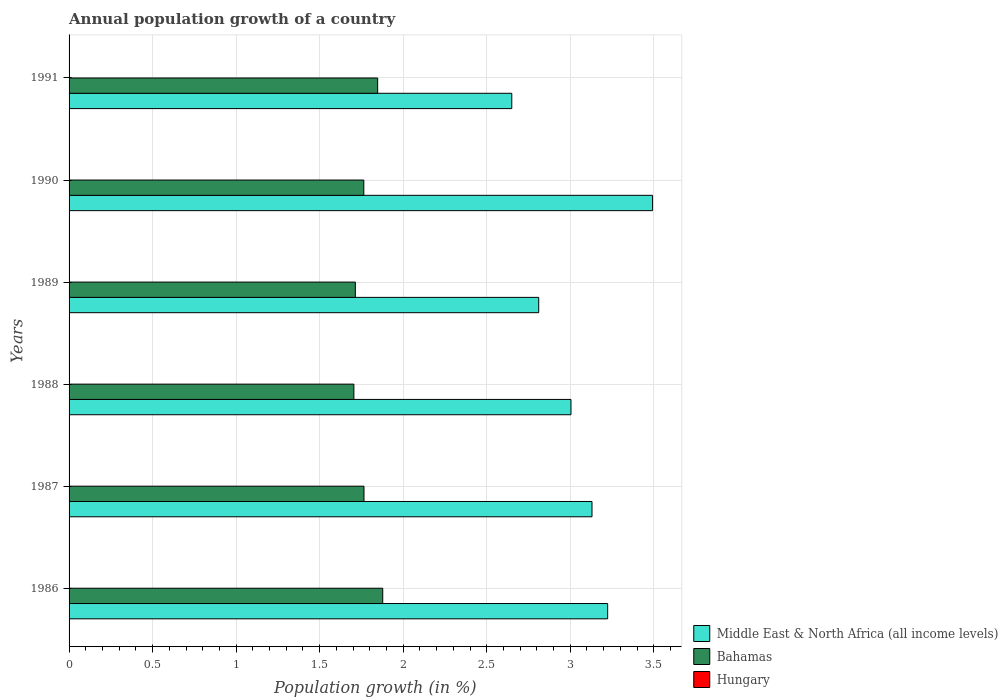How many different coloured bars are there?
Provide a succinct answer. 2. How many groups of bars are there?
Give a very brief answer. 6. Are the number of bars per tick equal to the number of legend labels?
Your answer should be very brief. No. Are the number of bars on each tick of the Y-axis equal?
Provide a short and direct response. Yes. How many bars are there on the 1st tick from the bottom?
Make the answer very short. 2. In how many cases, is the number of bars for a given year not equal to the number of legend labels?
Your response must be concise. 6. Across all years, what is the maximum annual population growth in Middle East & North Africa (all income levels)?
Your answer should be compact. 3.49. Across all years, what is the minimum annual population growth in Hungary?
Your response must be concise. 0. In which year was the annual population growth in Bahamas maximum?
Give a very brief answer. 1986. What is the difference between the annual population growth in Bahamas in 1986 and that in 1987?
Your response must be concise. 0.11. What is the difference between the annual population growth in Hungary in 1988 and the annual population growth in Bahamas in 1991?
Give a very brief answer. -1.85. What is the average annual population growth in Hungary per year?
Provide a succinct answer. 0. In the year 1989, what is the difference between the annual population growth in Bahamas and annual population growth in Middle East & North Africa (all income levels)?
Make the answer very short. -1.1. What is the ratio of the annual population growth in Middle East & North Africa (all income levels) in 1986 to that in 1990?
Your answer should be compact. 0.92. Is the difference between the annual population growth in Bahamas in 1987 and 1989 greater than the difference between the annual population growth in Middle East & North Africa (all income levels) in 1987 and 1989?
Provide a short and direct response. No. What is the difference between the highest and the second highest annual population growth in Bahamas?
Your answer should be very brief. 0.03. What is the difference between the highest and the lowest annual population growth in Middle East & North Africa (all income levels)?
Provide a short and direct response. 0.84. Is the sum of the annual population growth in Bahamas in 1987 and 1990 greater than the maximum annual population growth in Hungary across all years?
Keep it short and to the point. Yes. Is it the case that in every year, the sum of the annual population growth in Hungary and annual population growth in Bahamas is greater than the annual population growth in Middle East & North Africa (all income levels)?
Offer a terse response. No. Are all the bars in the graph horizontal?
Ensure brevity in your answer.  Yes. Are the values on the major ticks of X-axis written in scientific E-notation?
Your answer should be very brief. No. Does the graph contain any zero values?
Give a very brief answer. Yes. Does the graph contain grids?
Make the answer very short. Yes. Where does the legend appear in the graph?
Keep it short and to the point. Bottom right. How are the legend labels stacked?
Ensure brevity in your answer.  Vertical. What is the title of the graph?
Your response must be concise. Annual population growth of a country. Does "Mauritania" appear as one of the legend labels in the graph?
Offer a very short reply. No. What is the label or title of the X-axis?
Give a very brief answer. Population growth (in %). What is the Population growth (in %) in Middle East & North Africa (all income levels) in 1986?
Provide a short and direct response. 3.22. What is the Population growth (in %) of Bahamas in 1986?
Your answer should be compact. 1.88. What is the Population growth (in %) of Hungary in 1986?
Offer a terse response. 0. What is the Population growth (in %) of Middle East & North Africa (all income levels) in 1987?
Ensure brevity in your answer.  3.13. What is the Population growth (in %) of Bahamas in 1987?
Your answer should be very brief. 1.77. What is the Population growth (in %) of Hungary in 1987?
Keep it short and to the point. 0. What is the Population growth (in %) of Middle East & North Africa (all income levels) in 1988?
Keep it short and to the point. 3. What is the Population growth (in %) in Bahamas in 1988?
Provide a succinct answer. 1.7. What is the Population growth (in %) of Hungary in 1988?
Offer a very short reply. 0. What is the Population growth (in %) of Middle East & North Africa (all income levels) in 1989?
Give a very brief answer. 2.81. What is the Population growth (in %) of Bahamas in 1989?
Make the answer very short. 1.71. What is the Population growth (in %) in Middle East & North Africa (all income levels) in 1990?
Provide a short and direct response. 3.49. What is the Population growth (in %) in Bahamas in 1990?
Give a very brief answer. 1.76. What is the Population growth (in %) of Middle East & North Africa (all income levels) in 1991?
Your answer should be compact. 2.65. What is the Population growth (in %) in Bahamas in 1991?
Ensure brevity in your answer.  1.85. Across all years, what is the maximum Population growth (in %) of Middle East & North Africa (all income levels)?
Offer a terse response. 3.49. Across all years, what is the maximum Population growth (in %) of Bahamas?
Ensure brevity in your answer.  1.88. Across all years, what is the minimum Population growth (in %) in Middle East & North Africa (all income levels)?
Offer a very short reply. 2.65. Across all years, what is the minimum Population growth (in %) of Bahamas?
Keep it short and to the point. 1.7. What is the total Population growth (in %) of Middle East & North Africa (all income levels) in the graph?
Your response must be concise. 18.31. What is the total Population growth (in %) in Bahamas in the graph?
Provide a short and direct response. 10.67. What is the difference between the Population growth (in %) of Middle East & North Africa (all income levels) in 1986 and that in 1987?
Your answer should be very brief. 0.09. What is the difference between the Population growth (in %) in Bahamas in 1986 and that in 1987?
Give a very brief answer. 0.11. What is the difference between the Population growth (in %) of Middle East & North Africa (all income levels) in 1986 and that in 1988?
Make the answer very short. 0.22. What is the difference between the Population growth (in %) of Bahamas in 1986 and that in 1988?
Keep it short and to the point. 0.17. What is the difference between the Population growth (in %) in Middle East & North Africa (all income levels) in 1986 and that in 1989?
Your response must be concise. 0.41. What is the difference between the Population growth (in %) in Bahamas in 1986 and that in 1989?
Your answer should be compact. 0.16. What is the difference between the Population growth (in %) in Middle East & North Africa (all income levels) in 1986 and that in 1990?
Offer a very short reply. -0.27. What is the difference between the Population growth (in %) of Bahamas in 1986 and that in 1990?
Provide a short and direct response. 0.11. What is the difference between the Population growth (in %) of Middle East & North Africa (all income levels) in 1986 and that in 1991?
Offer a terse response. 0.57. What is the difference between the Population growth (in %) of Bahamas in 1986 and that in 1991?
Give a very brief answer. 0.03. What is the difference between the Population growth (in %) of Middle East & North Africa (all income levels) in 1987 and that in 1988?
Your response must be concise. 0.13. What is the difference between the Population growth (in %) of Bahamas in 1987 and that in 1988?
Keep it short and to the point. 0.06. What is the difference between the Population growth (in %) of Middle East & North Africa (all income levels) in 1987 and that in 1989?
Offer a very short reply. 0.32. What is the difference between the Population growth (in %) in Bahamas in 1987 and that in 1989?
Give a very brief answer. 0.05. What is the difference between the Population growth (in %) of Middle East & North Africa (all income levels) in 1987 and that in 1990?
Offer a very short reply. -0.36. What is the difference between the Population growth (in %) in Middle East & North Africa (all income levels) in 1987 and that in 1991?
Make the answer very short. 0.48. What is the difference between the Population growth (in %) in Bahamas in 1987 and that in 1991?
Your answer should be very brief. -0.08. What is the difference between the Population growth (in %) in Middle East & North Africa (all income levels) in 1988 and that in 1989?
Provide a succinct answer. 0.19. What is the difference between the Population growth (in %) of Bahamas in 1988 and that in 1989?
Provide a short and direct response. -0.01. What is the difference between the Population growth (in %) in Middle East & North Africa (all income levels) in 1988 and that in 1990?
Your answer should be very brief. -0.49. What is the difference between the Population growth (in %) of Bahamas in 1988 and that in 1990?
Make the answer very short. -0.06. What is the difference between the Population growth (in %) in Middle East & North Africa (all income levels) in 1988 and that in 1991?
Provide a short and direct response. 0.35. What is the difference between the Population growth (in %) in Bahamas in 1988 and that in 1991?
Keep it short and to the point. -0.14. What is the difference between the Population growth (in %) of Middle East & North Africa (all income levels) in 1989 and that in 1990?
Your answer should be compact. -0.68. What is the difference between the Population growth (in %) in Bahamas in 1989 and that in 1990?
Provide a short and direct response. -0.05. What is the difference between the Population growth (in %) in Middle East & North Africa (all income levels) in 1989 and that in 1991?
Make the answer very short. 0.16. What is the difference between the Population growth (in %) in Bahamas in 1989 and that in 1991?
Make the answer very short. -0.13. What is the difference between the Population growth (in %) in Middle East & North Africa (all income levels) in 1990 and that in 1991?
Your answer should be very brief. 0.84. What is the difference between the Population growth (in %) of Bahamas in 1990 and that in 1991?
Provide a short and direct response. -0.08. What is the difference between the Population growth (in %) in Middle East & North Africa (all income levels) in 1986 and the Population growth (in %) in Bahamas in 1987?
Provide a succinct answer. 1.46. What is the difference between the Population growth (in %) in Middle East & North Africa (all income levels) in 1986 and the Population growth (in %) in Bahamas in 1988?
Provide a short and direct response. 1.52. What is the difference between the Population growth (in %) in Middle East & North Africa (all income levels) in 1986 and the Population growth (in %) in Bahamas in 1989?
Keep it short and to the point. 1.51. What is the difference between the Population growth (in %) of Middle East & North Africa (all income levels) in 1986 and the Population growth (in %) of Bahamas in 1990?
Offer a terse response. 1.46. What is the difference between the Population growth (in %) of Middle East & North Africa (all income levels) in 1986 and the Population growth (in %) of Bahamas in 1991?
Your answer should be compact. 1.38. What is the difference between the Population growth (in %) in Middle East & North Africa (all income levels) in 1987 and the Population growth (in %) in Bahamas in 1988?
Ensure brevity in your answer.  1.43. What is the difference between the Population growth (in %) in Middle East & North Africa (all income levels) in 1987 and the Population growth (in %) in Bahamas in 1989?
Offer a very short reply. 1.42. What is the difference between the Population growth (in %) of Middle East & North Africa (all income levels) in 1987 and the Population growth (in %) of Bahamas in 1990?
Your answer should be compact. 1.37. What is the difference between the Population growth (in %) of Middle East & North Africa (all income levels) in 1987 and the Population growth (in %) of Bahamas in 1991?
Give a very brief answer. 1.28. What is the difference between the Population growth (in %) of Middle East & North Africa (all income levels) in 1988 and the Population growth (in %) of Bahamas in 1989?
Keep it short and to the point. 1.29. What is the difference between the Population growth (in %) in Middle East & North Africa (all income levels) in 1988 and the Population growth (in %) in Bahamas in 1990?
Offer a very short reply. 1.24. What is the difference between the Population growth (in %) in Middle East & North Africa (all income levels) in 1988 and the Population growth (in %) in Bahamas in 1991?
Ensure brevity in your answer.  1.16. What is the difference between the Population growth (in %) of Middle East & North Africa (all income levels) in 1989 and the Population growth (in %) of Bahamas in 1990?
Make the answer very short. 1.05. What is the difference between the Population growth (in %) in Middle East & North Africa (all income levels) in 1989 and the Population growth (in %) in Bahamas in 1991?
Keep it short and to the point. 0.96. What is the difference between the Population growth (in %) in Middle East & North Africa (all income levels) in 1990 and the Population growth (in %) in Bahamas in 1991?
Ensure brevity in your answer.  1.65. What is the average Population growth (in %) in Middle East & North Africa (all income levels) per year?
Your answer should be very brief. 3.05. What is the average Population growth (in %) of Bahamas per year?
Your answer should be compact. 1.78. What is the average Population growth (in %) in Hungary per year?
Keep it short and to the point. 0. In the year 1986, what is the difference between the Population growth (in %) in Middle East & North Africa (all income levels) and Population growth (in %) in Bahamas?
Ensure brevity in your answer.  1.35. In the year 1987, what is the difference between the Population growth (in %) of Middle East & North Africa (all income levels) and Population growth (in %) of Bahamas?
Provide a short and direct response. 1.36. In the year 1988, what is the difference between the Population growth (in %) of Middle East & North Africa (all income levels) and Population growth (in %) of Bahamas?
Offer a terse response. 1.3. In the year 1989, what is the difference between the Population growth (in %) of Middle East & North Africa (all income levels) and Population growth (in %) of Bahamas?
Provide a succinct answer. 1.1. In the year 1990, what is the difference between the Population growth (in %) in Middle East & North Africa (all income levels) and Population growth (in %) in Bahamas?
Keep it short and to the point. 1.73. In the year 1991, what is the difference between the Population growth (in %) of Middle East & North Africa (all income levels) and Population growth (in %) of Bahamas?
Make the answer very short. 0.8. What is the ratio of the Population growth (in %) of Middle East & North Africa (all income levels) in 1986 to that in 1987?
Your answer should be compact. 1.03. What is the ratio of the Population growth (in %) of Bahamas in 1986 to that in 1987?
Your answer should be compact. 1.06. What is the ratio of the Population growth (in %) of Middle East & North Africa (all income levels) in 1986 to that in 1988?
Offer a very short reply. 1.07. What is the ratio of the Population growth (in %) of Bahamas in 1986 to that in 1988?
Provide a succinct answer. 1.1. What is the ratio of the Population growth (in %) of Middle East & North Africa (all income levels) in 1986 to that in 1989?
Ensure brevity in your answer.  1.15. What is the ratio of the Population growth (in %) in Bahamas in 1986 to that in 1989?
Give a very brief answer. 1.1. What is the ratio of the Population growth (in %) of Middle East & North Africa (all income levels) in 1986 to that in 1990?
Give a very brief answer. 0.92. What is the ratio of the Population growth (in %) of Bahamas in 1986 to that in 1990?
Give a very brief answer. 1.06. What is the ratio of the Population growth (in %) in Middle East & North Africa (all income levels) in 1986 to that in 1991?
Give a very brief answer. 1.22. What is the ratio of the Population growth (in %) of Bahamas in 1986 to that in 1991?
Offer a terse response. 1.02. What is the ratio of the Population growth (in %) of Middle East & North Africa (all income levels) in 1987 to that in 1988?
Ensure brevity in your answer.  1.04. What is the ratio of the Population growth (in %) of Bahamas in 1987 to that in 1988?
Your answer should be compact. 1.04. What is the ratio of the Population growth (in %) of Middle East & North Africa (all income levels) in 1987 to that in 1989?
Make the answer very short. 1.11. What is the ratio of the Population growth (in %) of Bahamas in 1987 to that in 1989?
Your response must be concise. 1.03. What is the ratio of the Population growth (in %) of Middle East & North Africa (all income levels) in 1987 to that in 1990?
Offer a terse response. 0.9. What is the ratio of the Population growth (in %) of Bahamas in 1987 to that in 1990?
Provide a succinct answer. 1. What is the ratio of the Population growth (in %) in Middle East & North Africa (all income levels) in 1987 to that in 1991?
Keep it short and to the point. 1.18. What is the ratio of the Population growth (in %) in Bahamas in 1987 to that in 1991?
Give a very brief answer. 0.96. What is the ratio of the Population growth (in %) in Middle East & North Africa (all income levels) in 1988 to that in 1989?
Your response must be concise. 1.07. What is the ratio of the Population growth (in %) in Middle East & North Africa (all income levels) in 1988 to that in 1990?
Make the answer very short. 0.86. What is the ratio of the Population growth (in %) in Bahamas in 1988 to that in 1990?
Offer a terse response. 0.97. What is the ratio of the Population growth (in %) of Middle East & North Africa (all income levels) in 1988 to that in 1991?
Your response must be concise. 1.13. What is the ratio of the Population growth (in %) of Bahamas in 1988 to that in 1991?
Provide a succinct answer. 0.92. What is the ratio of the Population growth (in %) of Middle East & North Africa (all income levels) in 1989 to that in 1990?
Your response must be concise. 0.8. What is the ratio of the Population growth (in %) in Bahamas in 1989 to that in 1990?
Make the answer very short. 0.97. What is the ratio of the Population growth (in %) of Middle East & North Africa (all income levels) in 1989 to that in 1991?
Your answer should be compact. 1.06. What is the ratio of the Population growth (in %) in Bahamas in 1989 to that in 1991?
Your answer should be compact. 0.93. What is the ratio of the Population growth (in %) of Middle East & North Africa (all income levels) in 1990 to that in 1991?
Your answer should be compact. 1.32. What is the ratio of the Population growth (in %) in Bahamas in 1990 to that in 1991?
Offer a very short reply. 0.96. What is the difference between the highest and the second highest Population growth (in %) of Middle East & North Africa (all income levels)?
Your answer should be compact. 0.27. What is the difference between the highest and the second highest Population growth (in %) in Bahamas?
Provide a succinct answer. 0.03. What is the difference between the highest and the lowest Population growth (in %) of Middle East & North Africa (all income levels)?
Keep it short and to the point. 0.84. What is the difference between the highest and the lowest Population growth (in %) in Bahamas?
Your answer should be very brief. 0.17. 